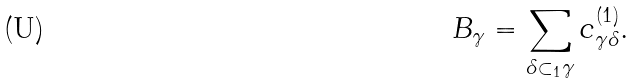<formula> <loc_0><loc_0><loc_500><loc_500>B _ { \gamma } = \sum _ { \delta \subset _ { 1 } \gamma } c _ { \gamma \delta } ^ { ( 1 ) } .</formula> 